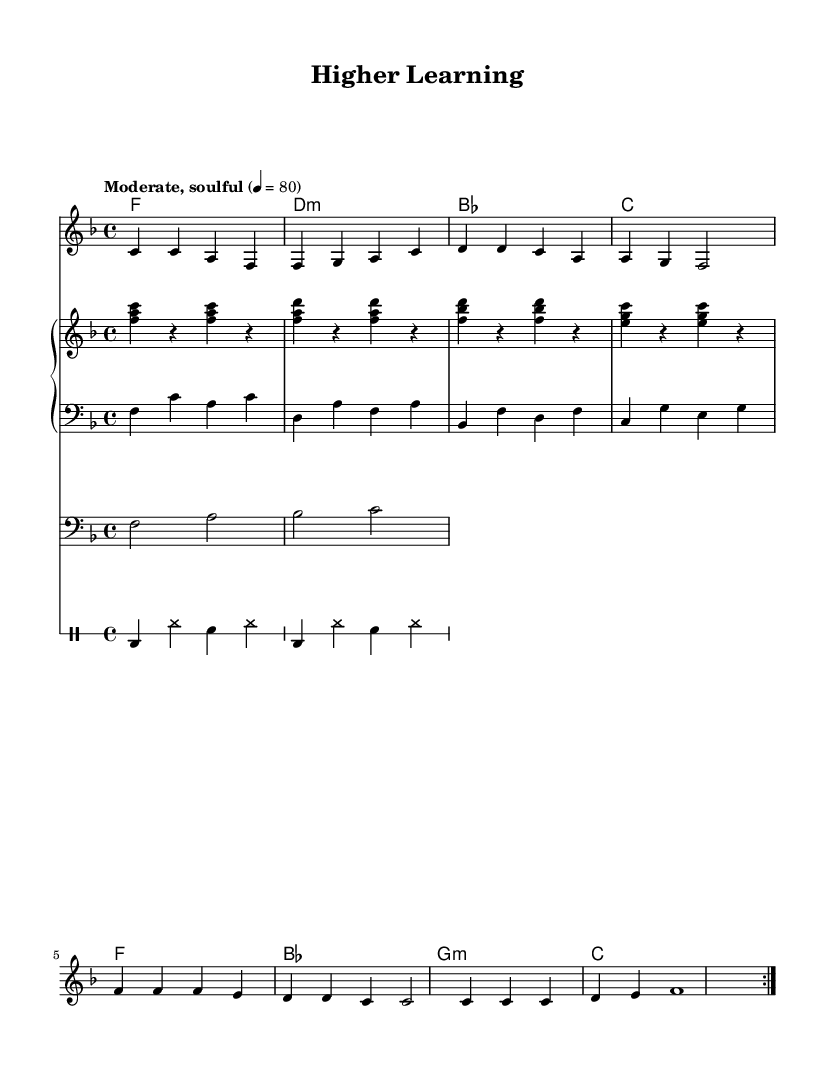What is the key signature of this music? The key signature is F major, which includes one flat (B flat). This is determined by looking at the key signature indicator at the beginning of the staff.
Answer: F major What is the time signature of this piece? The time signature is 4/4, as indicated at the beginning of the score. This means there are four beats in each measure and the quarter note gets one beat.
Answer: 4/4 What is the tempo marking given in the music? The tempo marking is "Moderate, soulful," which describes the pace at which the piece should be played. The number above (4 = 80) indicates that a quarter note should be played at 80 beats per minute.
Answer: Moderate, soulful How many times is the melody section repeated? The melody section is repeated twice, as indicated by the "repeat volta 2" directive in the melody part. This means the section should be played, then played again.
Answer: 2 What are the first two lyrics sung in the verse? The first two lyrics sung are "Late nights and long days," which can be found aligned with the first notes of the melody in the lyrics section.
Answer: Late nights and long days What emotions do the lyrics convey regarding pursuing a degree? The lyrics convey determination and perseverance, as shown through phrases like "no mountain too steep, no challenge too big for me." This indicates a strong will to overcome obstacles in pursuit of education.
Answer: Determination and perseverance How many different chord progressions are present in this music? There are four different chord progressions in the harmonic section: F, D minor, B flat, and C major. Each chord signifies a shift in harmony and supports the melody.
Answer: 4 